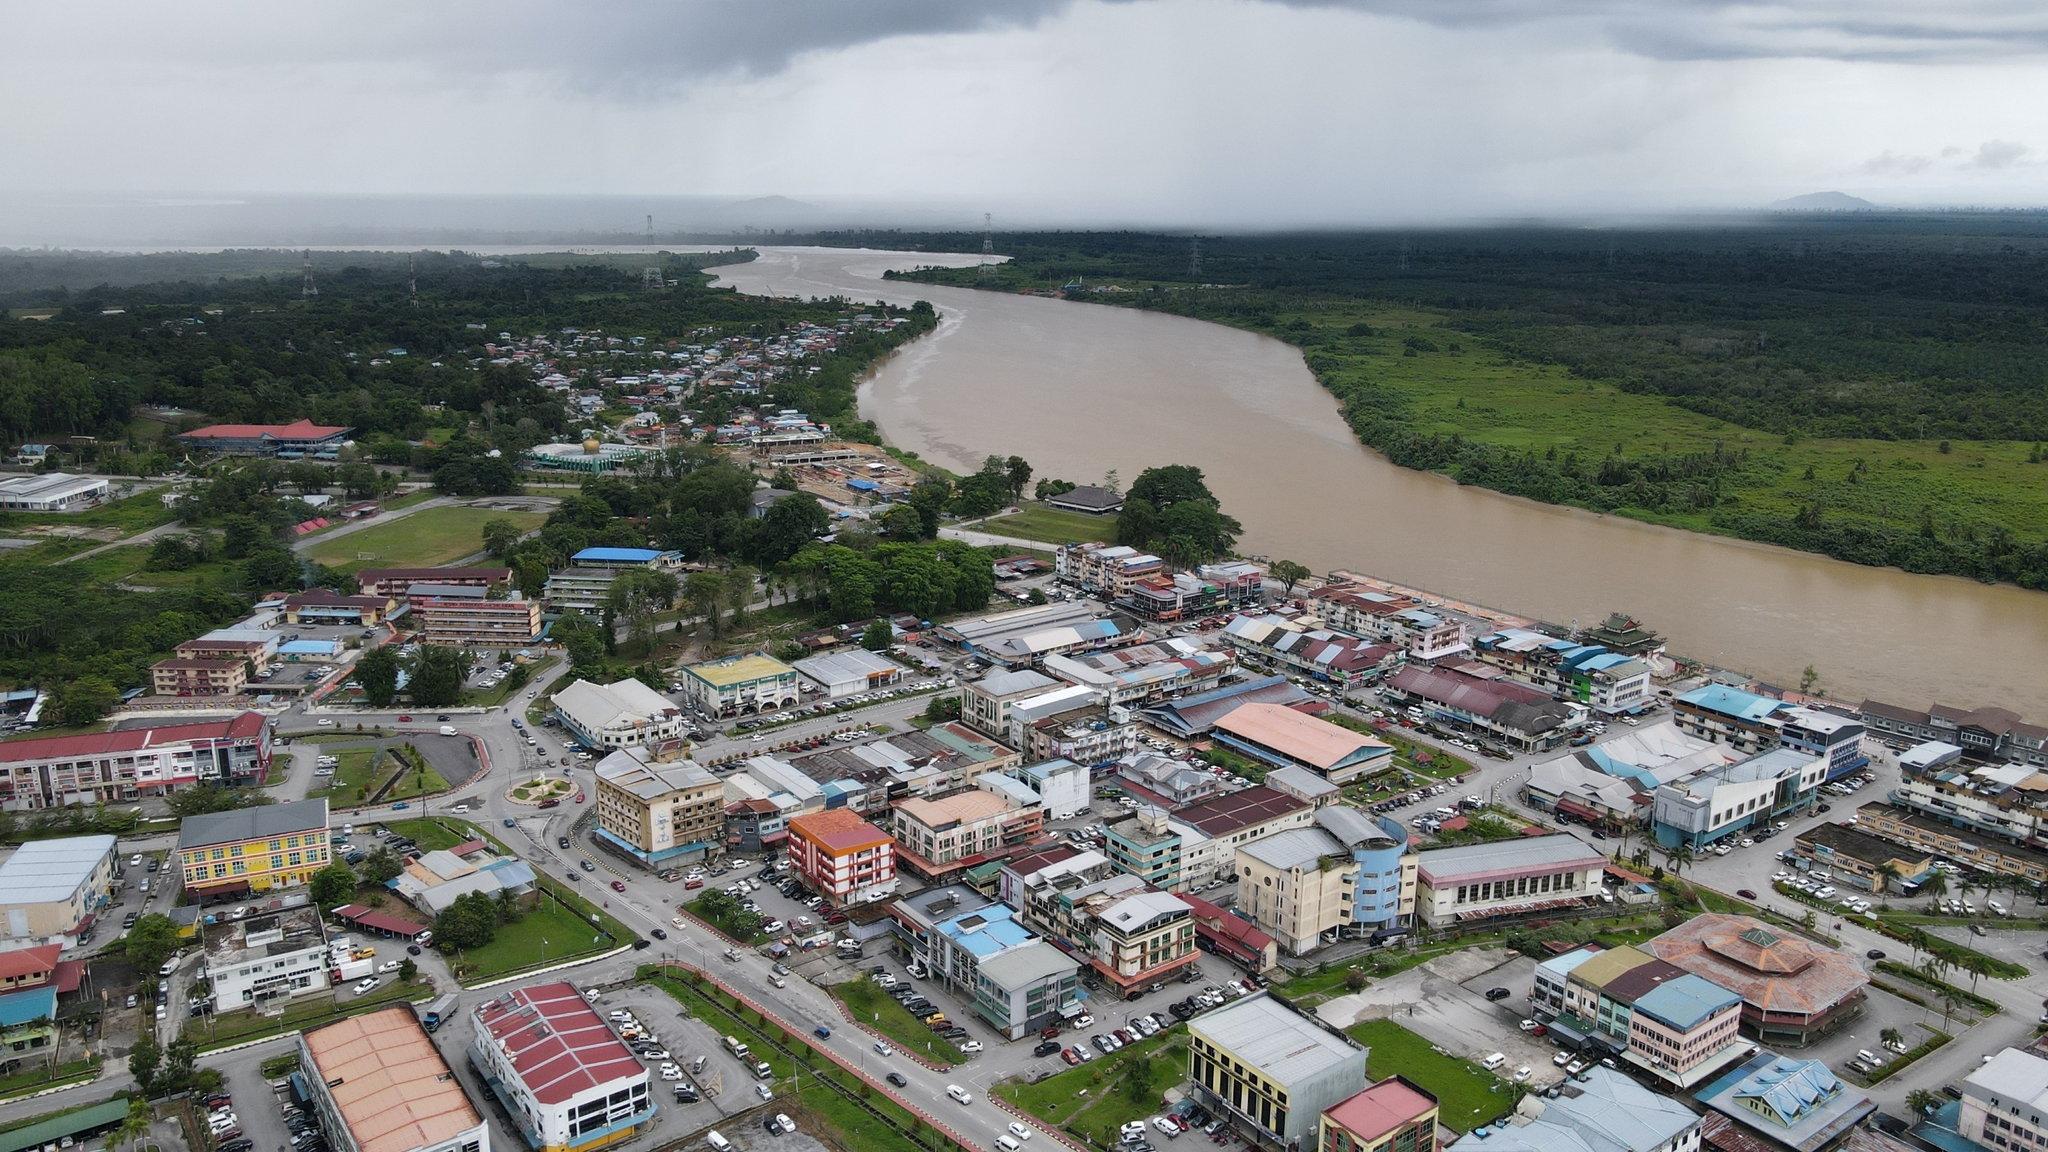Imagine a mythical creature lives in this river. What might it be, and how does it interact with the town? Legend speaks of a mystical river serpent named Seraphein that dwells in the depths of this wide, brown river. Seraphein is said to be a guardian spirit of the town, emerging only during times of great need. The townsfolk hold festivals in its honor, offering tributes to ensure its protection and blessings. At midnight, under a full moon, some claim to have seen Seraphein's luminescent scales shimmering beneath the water's surface, a sign of its watchful presence. The creature is believed to bring abundant fish to the river, ensuring the town's prosperity, and its occasional roars are interpreted as warnings of impending natural events like floods or storms. The town's folklore, passed down through generations, tells tales of Seraphein's interactions with the town's ancestors, stories that continue to captivate and unite the community. Can you tell more about these festivals? The festivals dedicated to Seraphein are vibrant and joyous occasions, celebrated twice a year—during the harvest season and at the beginning of the rainy season. The streets of the town are adorned with colorful banners and lights. Residents don traditional attire and participate in a grand parade that winds its way through the town to the riverbanks. At the river, a large altar is constructed where offerings of fruits, flowers, and small crafted boats filled with symbolic gifts are presented to the river. The highlight of the festival is a theatrical reenactment of the legendary encounters between the townspeople and Seraphein, with local actors bringing the ancient tales to life through music, dance, and storytelling. The air is filled with the sound of drumbeats and cheerful songs, reflecting the community's deep appreciation and reverence for their mythical protector. As night falls, lanterns are released onto the river, illuminating the water in a mesmerizing dance of light, symbolizing hope and the town’s enduring connection with Seraphein. 